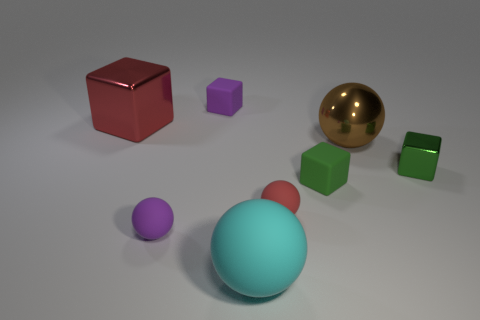How does the lighting in the image affect the appearance of the objects? The lighting creates soft shadows and highlights, which help to accentuate the three-dimensional form of each object. It also enhances the texture differences—note how the shiny sphere reflects the light, while the matte surfaces of the other shapes absorb it. 